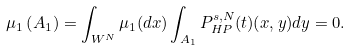Convert formula to latex. <formula><loc_0><loc_0><loc_500><loc_500>\mu _ { 1 } \left ( A _ { 1 } \right ) = \int _ { W ^ { N } } \mu _ { 1 } ( d x ) \int _ { A _ { 1 } } P _ { H P } ^ { s , N } ( t ) ( x , y ) d y = 0 .</formula> 